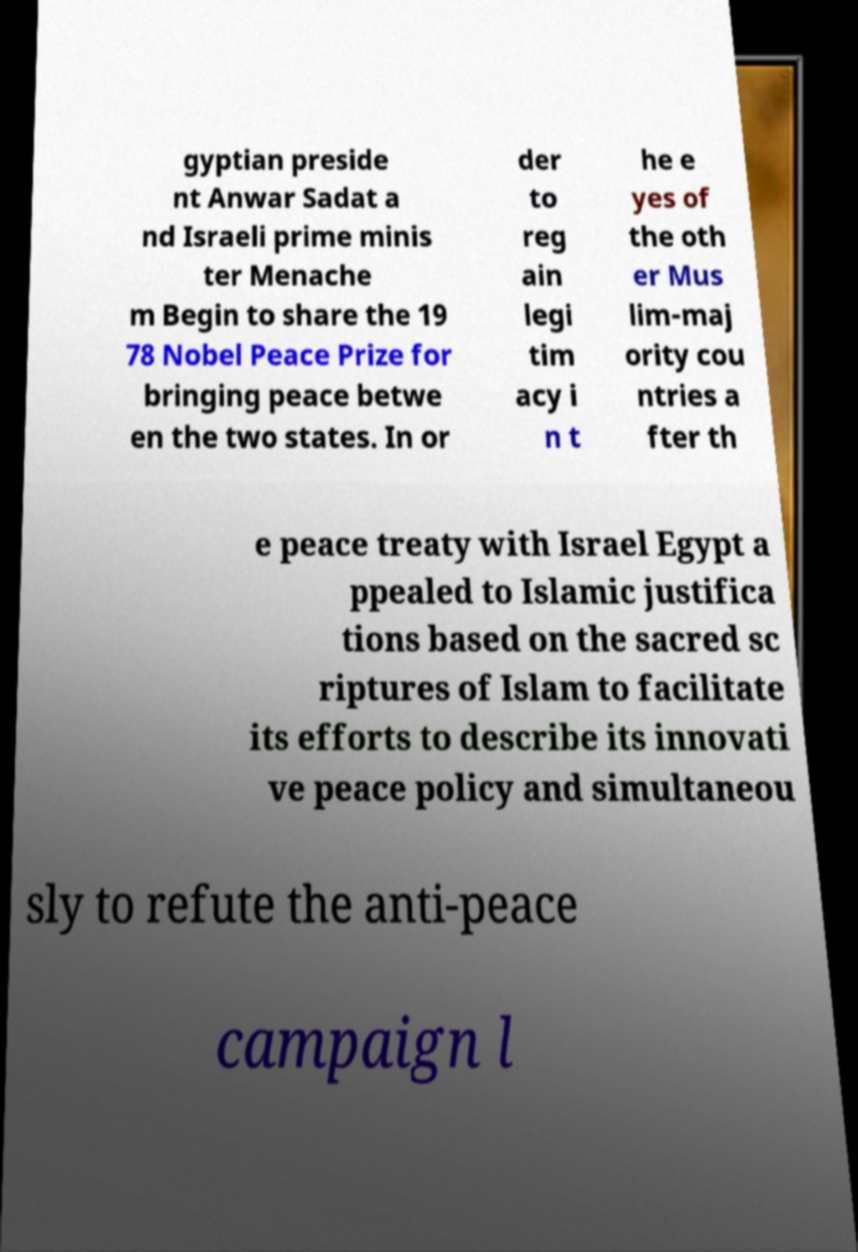For documentation purposes, I need the text within this image transcribed. Could you provide that? gyptian preside nt Anwar Sadat a nd Israeli prime minis ter Menache m Begin to share the 19 78 Nobel Peace Prize for bringing peace betwe en the two states. In or der to reg ain legi tim acy i n t he e yes of the oth er Mus lim-maj ority cou ntries a fter th e peace treaty with Israel Egypt a ppealed to Islamic justifica tions based on the sacred sc riptures of Islam to facilitate its efforts to describe its innovati ve peace policy and simultaneou sly to refute the anti-peace campaign l 